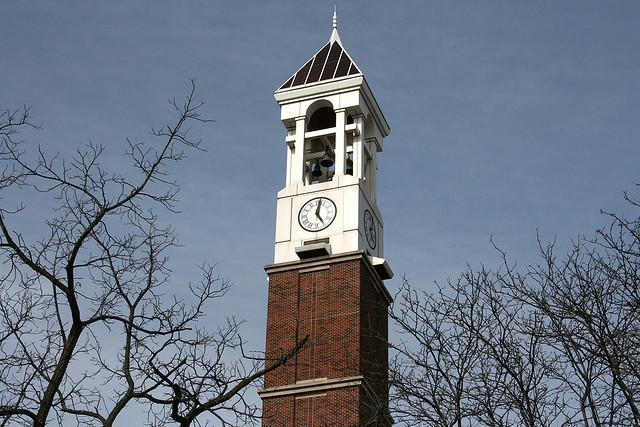How many keyboards are there?
Give a very brief answer. 0. 